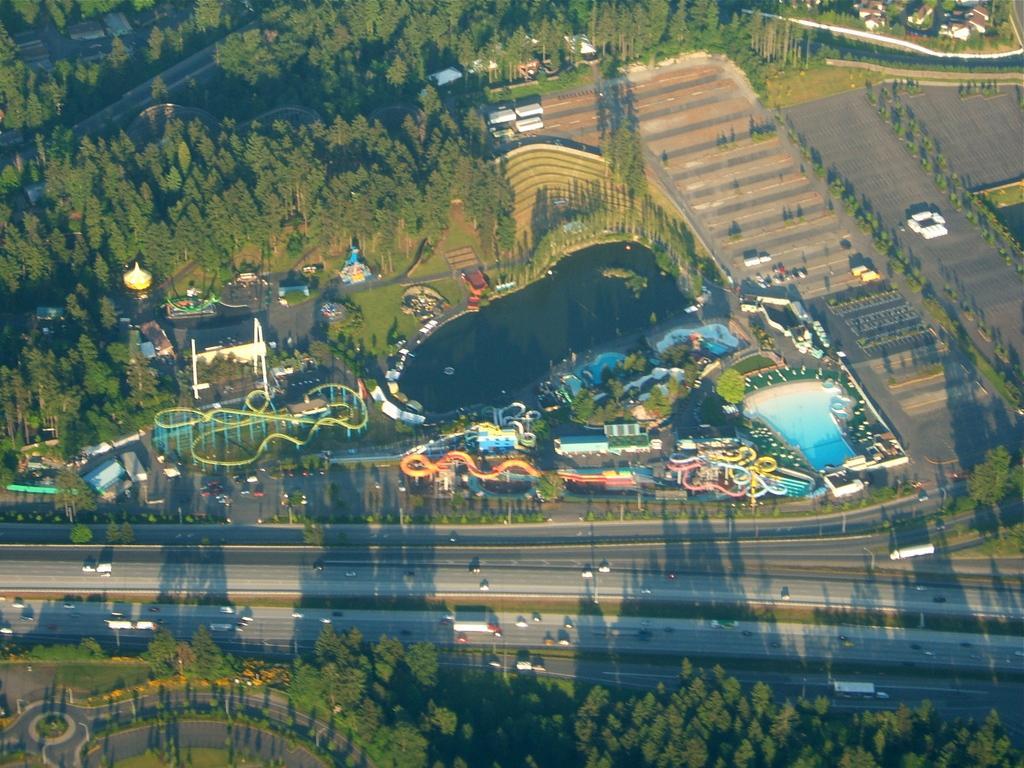Can you describe this image briefly? This is an aerial view where we can see trees, grassy land, vehicles, rides, swimming pool, plants, roads and a pond. 